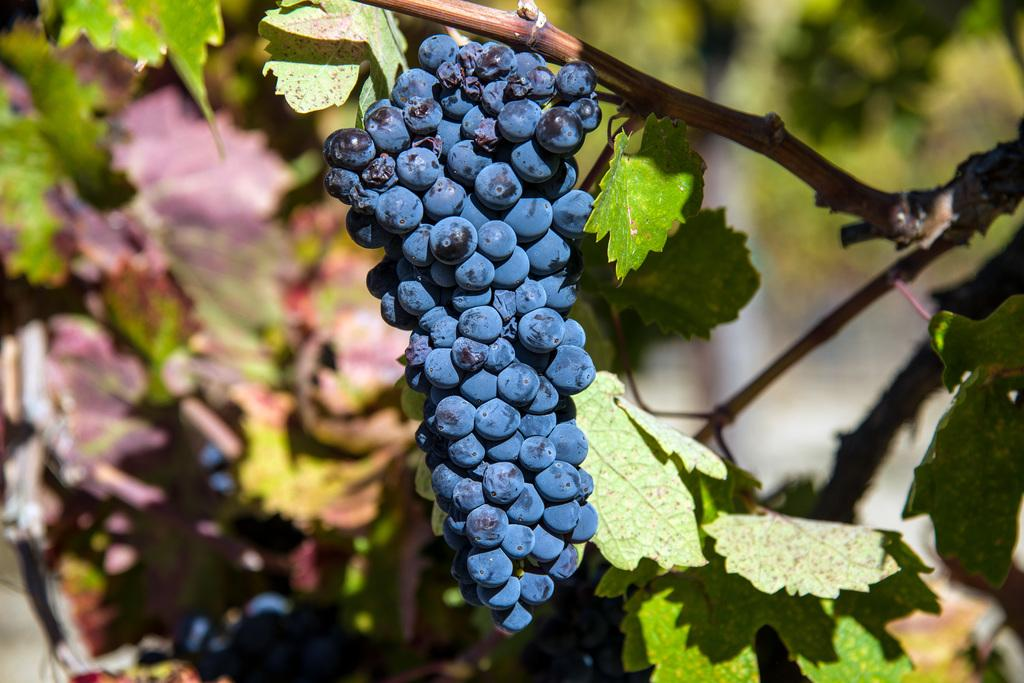Where was the image taken? The image was taken outdoors. What type of plant can be seen in the image? There is a grape plant in the image. What color are the leaves of the grape plant? The leaves of the grape plant are green. What color are the stems of the grape plant? The stems of the grape plant are green. What type of fruit is growing on the grape plant? There are grapes on the grape plant. Can you see any attractions or amusement parks near the grape plant in the image? There is no mention of any attractions or amusement parks in the image; it only features a grape plant with green leaves and stems, and grapes. 